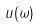<formula> <loc_0><loc_0><loc_500><loc_500>u ( \omega )</formula> 